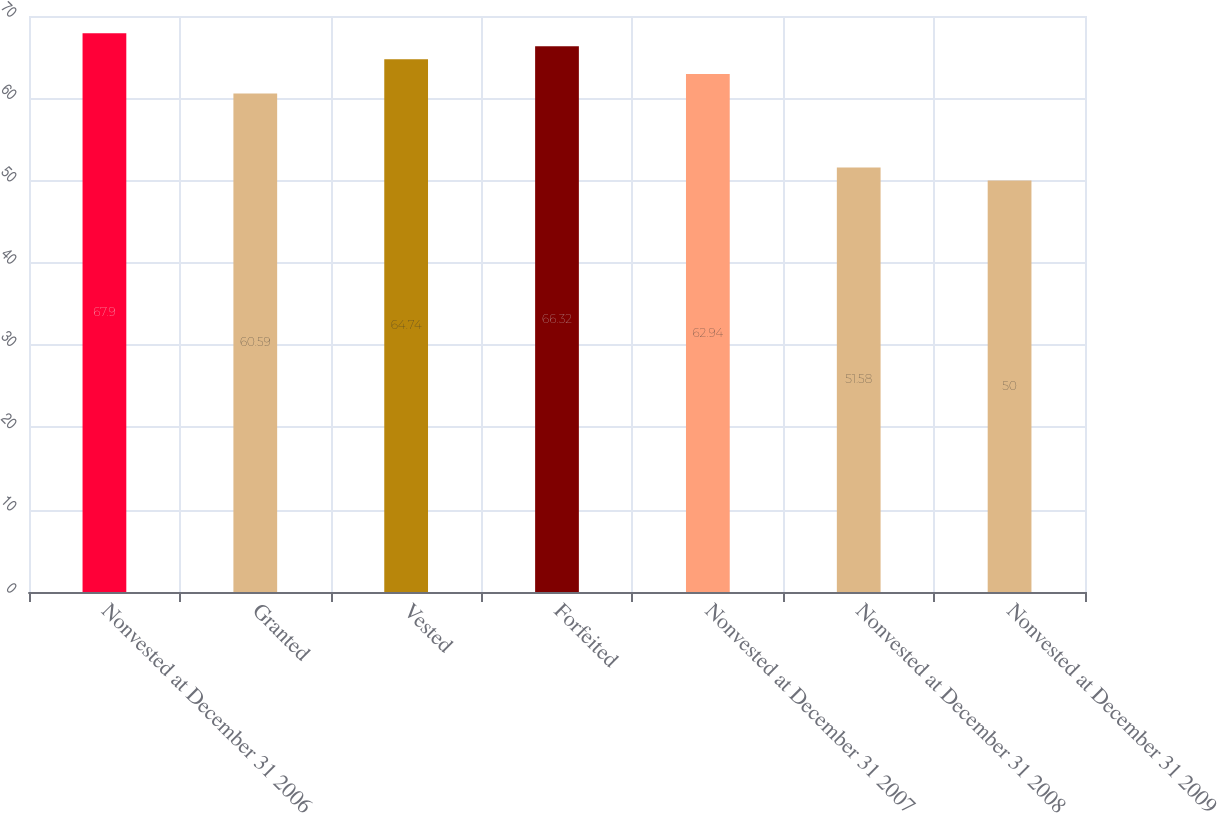Convert chart. <chart><loc_0><loc_0><loc_500><loc_500><bar_chart><fcel>Nonvested at December 31 2006<fcel>Granted<fcel>Vested<fcel>Forfeited<fcel>Nonvested at December 31 2007<fcel>Nonvested at December 31 2008<fcel>Nonvested at December 31 2009<nl><fcel>67.9<fcel>60.59<fcel>64.74<fcel>66.32<fcel>62.94<fcel>51.58<fcel>50<nl></chart> 